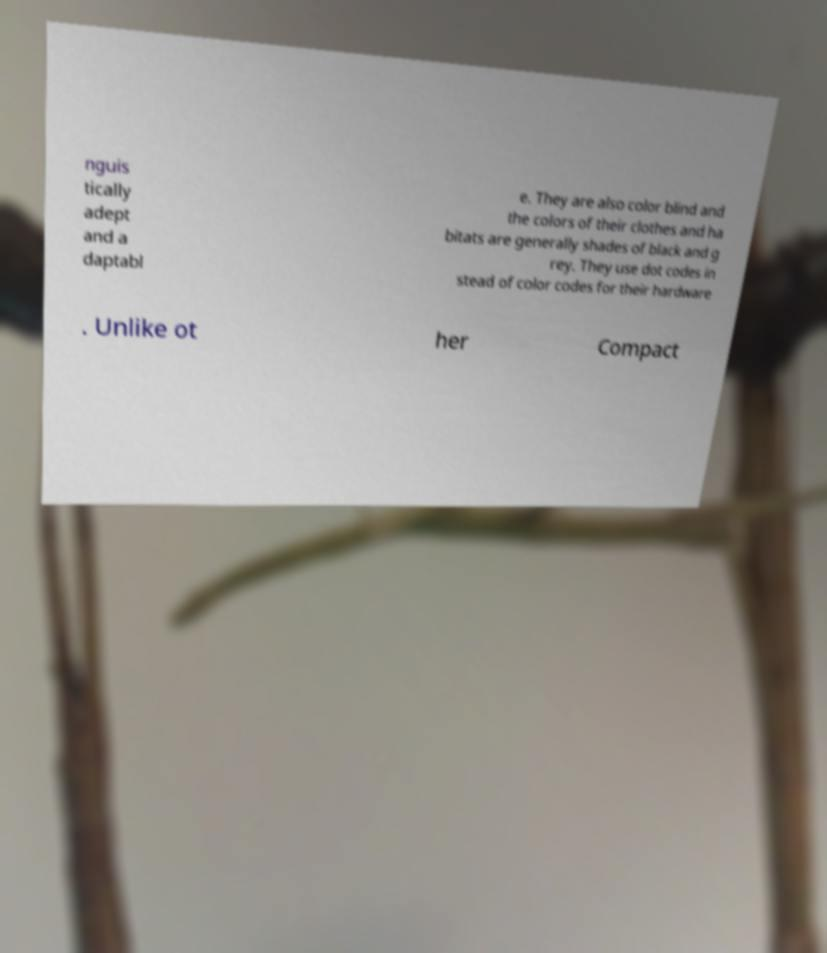Could you assist in decoding the text presented in this image and type it out clearly? nguis tically adept and a daptabl e. They are also color blind and the colors of their clothes and ha bitats are generally shades of black and g rey. They use dot codes in stead of color codes for their hardware . Unlike ot her Compact 